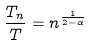<formula> <loc_0><loc_0><loc_500><loc_500>\frac { T _ { n } } { T } = n ^ { \frac { 1 } { 2 - \alpha } }</formula> 